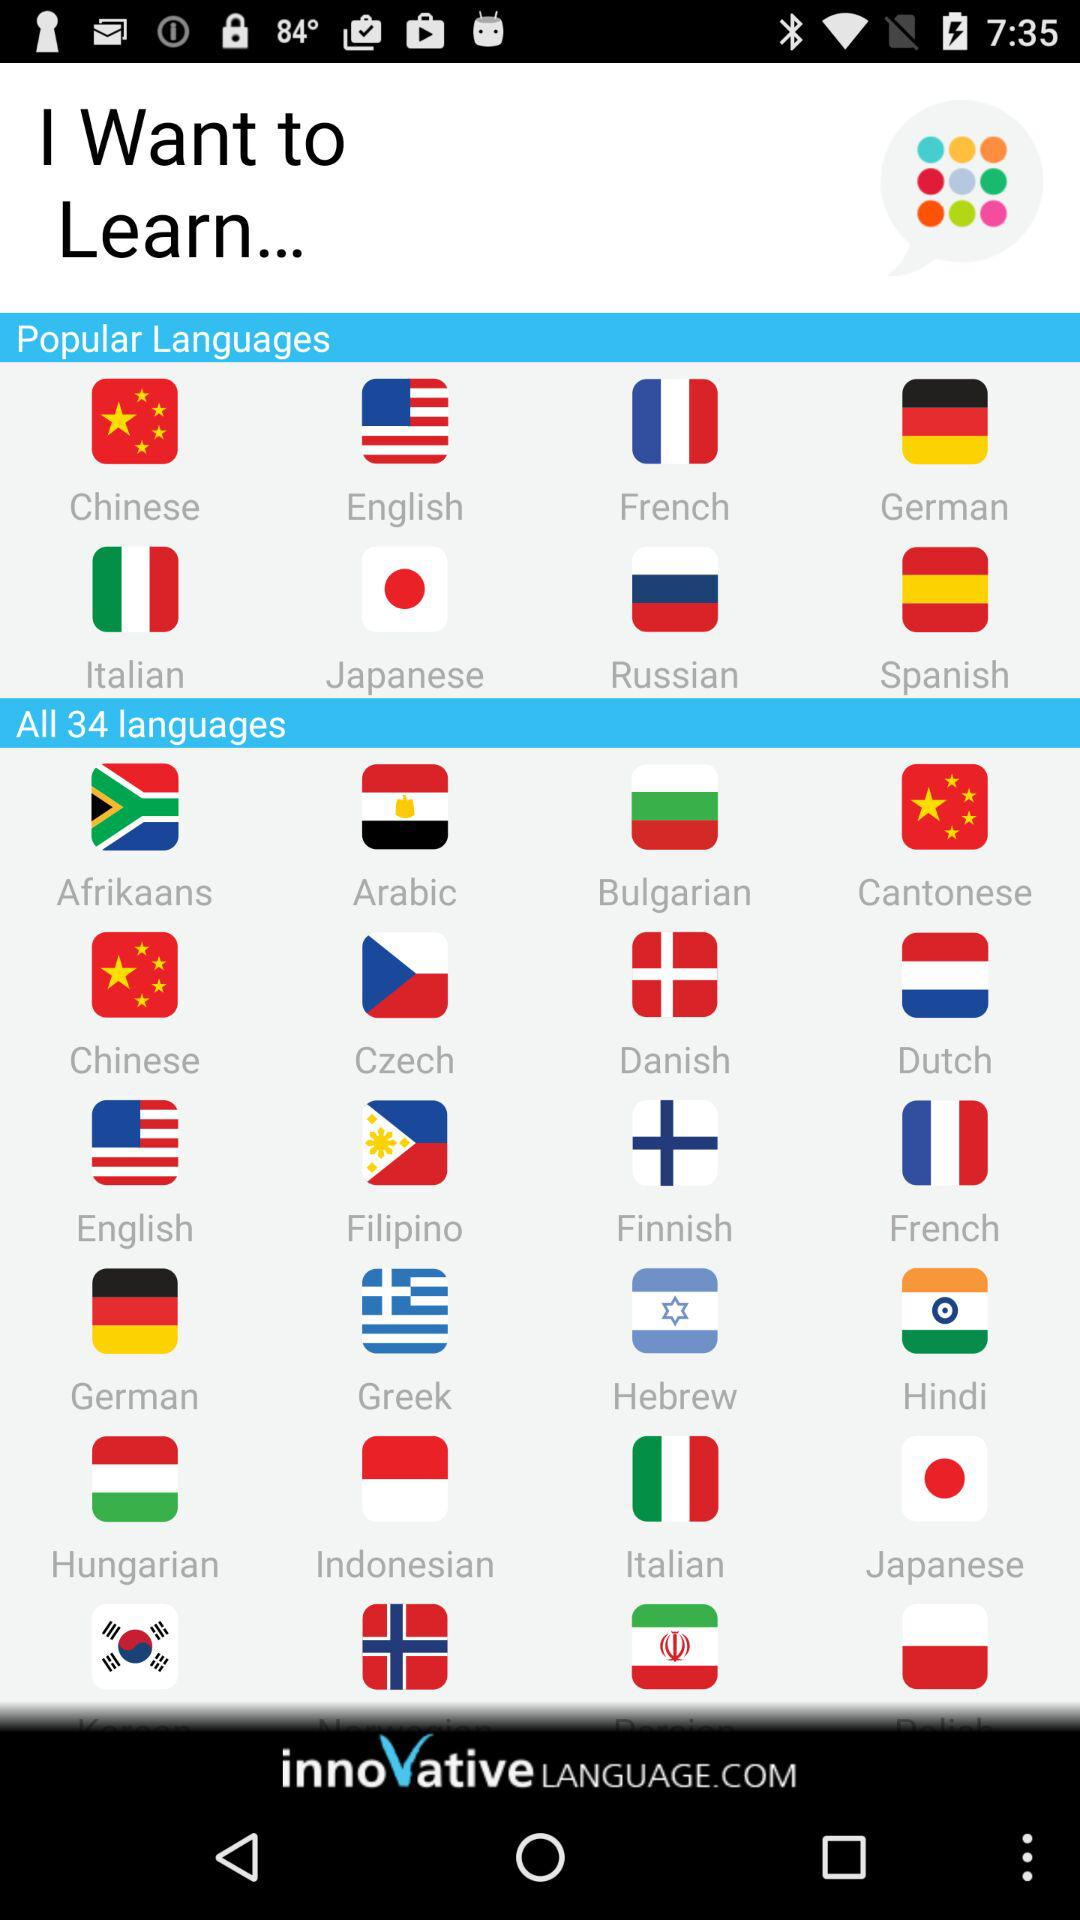What is the application name? The application name is "innovative LANGUAGE.COM". 